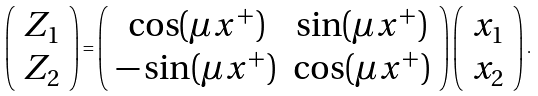Convert formula to latex. <formula><loc_0><loc_0><loc_500><loc_500>\left ( \begin{array} { c } { { Z _ { 1 } } } \\ { { Z _ { 2 } } } \end{array} \right ) = \left ( \begin{array} { c c } { { \cos ( \mu x ^ { + } ) } } & { { \sin ( \mu x ^ { + } ) } } \\ { { - \sin ( \mu x ^ { + } ) } } & { { \cos ( \mu x ^ { + } ) } } \end{array} \right ) \left ( \begin{array} { c } { { x _ { 1 } } } \\ { { x _ { 2 } } } \end{array} \right ) .</formula> 